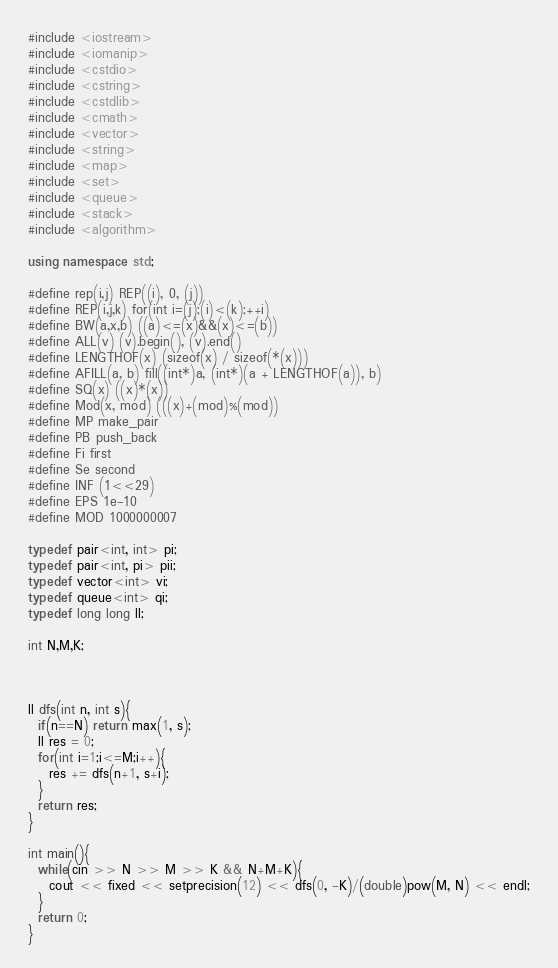Convert code to text. <code><loc_0><loc_0><loc_500><loc_500><_C++_>#include <iostream>
#include <iomanip>
#include <cstdio>
#include <cstring>
#include <cstdlib>
#include <cmath>
#include <vector>
#include <string>
#include <map>
#include <set>
#include <queue>
#include <stack>
#include <algorithm>

using namespace std;

#define rep(i,j) REP((i), 0, (j))
#define REP(i,j,k) for(int i=(j);(i)<(k);++i)
#define BW(a,x,b) ((a)<=(x)&&(x)<=(b))
#define ALL(v) (v).begin(), (v).end()
#define LENGTHOF(x) (sizeof(x) / sizeof(*(x)))
#define AFILL(a, b) fill((int*)a, (int*)(a + LENGTHOF(a)), b)
#define SQ(x) ((x)*(x))
#define Mod(x, mod) (((x)+(mod)%(mod))
#define MP make_pair
#define PB push_back
#define Fi first
#define Se second
#define INF (1<<29)
#define EPS 1e-10
#define MOD 1000000007

typedef pair<int, int> pi;
typedef pair<int, pi> pii;
typedef vector<int> vi;
typedef queue<int> qi;
typedef long long ll;

int N,M,K;



ll dfs(int n, int s){
  if(n==N) return max(1, s);
  ll res = 0;
  for(int i=1;i<=M;i++){
    res += dfs(n+1, s+i);
  }
  return res;
}

int main(){
  while(cin >> N >> M >> K && N+M+K){
    cout << fixed << setprecision(12) << dfs(0, -K)/(double)pow(M, N) << endl;
  }
  return 0;
}</code> 